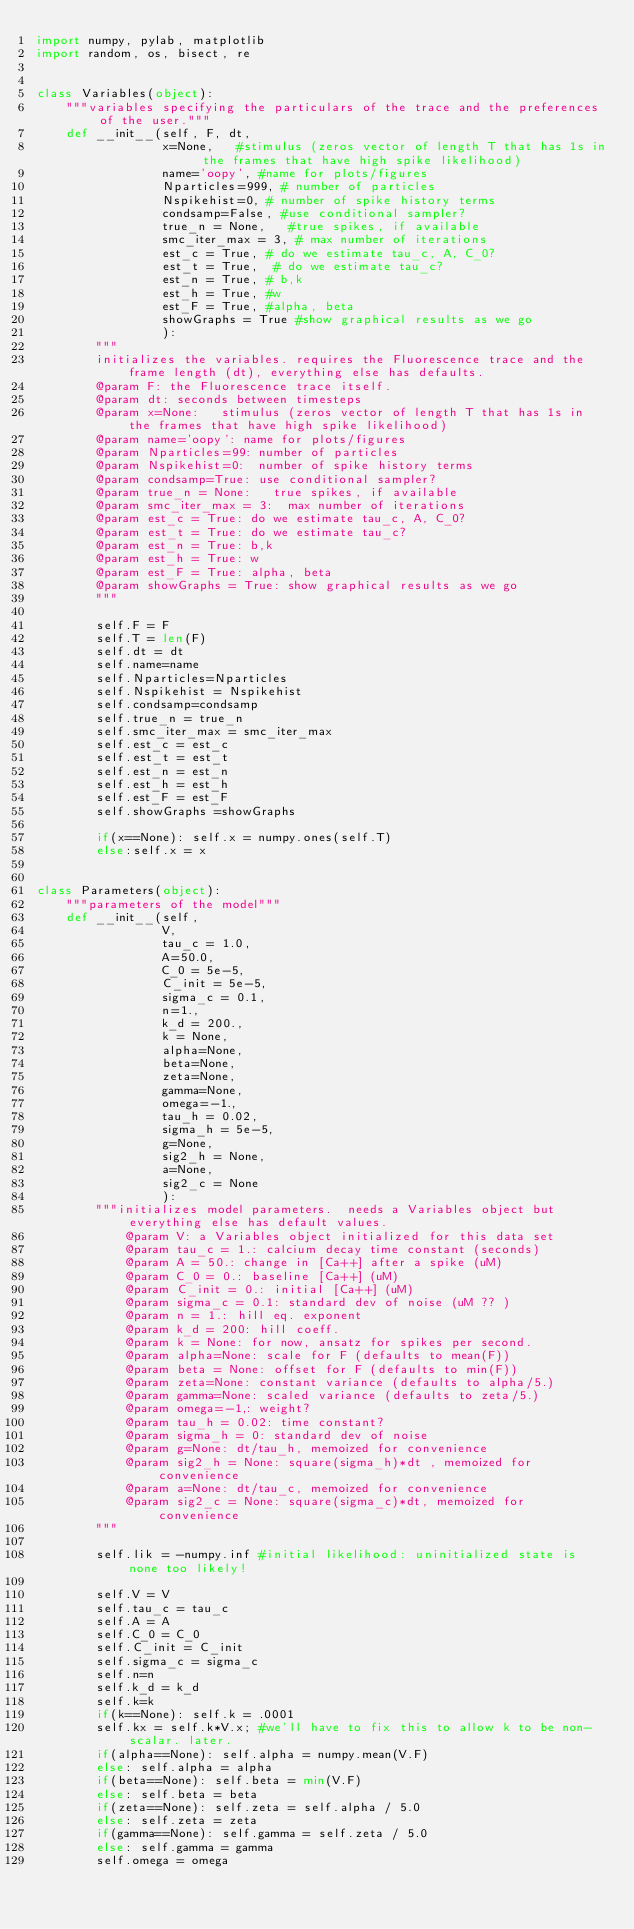<code> <loc_0><loc_0><loc_500><loc_500><_Python_>import numpy, pylab, matplotlib
import random, os, bisect, re


class Variables(object):
    """variables specifying the particulars of the trace and the preferences of the user."""
    def __init__(self, F, dt, 
                 x=None,   #stimulus (zeros vector of length T that has 1s in the frames that have high spike likelihood)
                 name='oopy', #name for plots/figures
                 Nparticles=999, # number of particles
                 Nspikehist=0, # number of spike history terms
                 condsamp=False, #use conditional sampler?
                 true_n = None,   #true spikes, if available
                 smc_iter_max = 3, # max number of iterations
                 est_c = True, # do we estimate tau_c, A, C_0?
                 est_t = True,  # do we estimate tau_c?
                 est_n = True, # b,k
                 est_h = True, #w
                 est_F = True, #alpha, beta
                 showGraphs = True #show graphical results as we go
                 ):
        """
        initializes the variables. requires the Fluorescence trace and the frame length (dt), everything else has defaults.
        @param F: the Fluorescence trace itself.
        @param dt: seconds between timesteps
        @param x=None:   stimulus (zeros vector of length T that has 1s in the frames that have high spike likelihood)
        @param name='oopy': name for plots/figures
        @param Nparticles=99: number of particles
        @param Nspikehist=0:  number of spike history terms
        @param condsamp=True: use conditional sampler?
        @param true_n = None:   true spikes, if available
        @param smc_iter_max = 3:  max number of iterations
        @param est_c = True: do we estimate tau_c, A, C_0?
        @param est_t = True: do we estimate tau_c?
        @param est_n = True: b,k
        @param est_h = True: w
        @param est_F = True: alpha, beta
        @param showGraphs = True: show graphical results as we go
        """
       
        self.F = F
        self.T = len(F)
        self.dt = dt
        self.name=name
        self.Nparticles=Nparticles
        self.Nspikehist = Nspikehist
        self.condsamp=condsamp
        self.true_n = true_n
        self.smc_iter_max = smc_iter_max
        self.est_c = est_c
        self.est_t = est_t
        self.est_n = est_n
        self.est_h = est_h
        self.est_F = est_F
        self.showGraphs =showGraphs
        
        if(x==None): self.x = numpy.ones(self.T)
        else:self.x = x
        

class Parameters(object):
    """parameters of the model"""
    def __init__(self, 
                 V, 
                 tau_c = 1.0,
                 A=50.0,
                 C_0 = 5e-5,
                 C_init = 5e-5,
                 sigma_c = 0.1,
                 n=1.,
                 k_d = 200.,
                 k = None,
                 alpha=None,
                 beta=None, 
                 zeta=None,
                 gamma=None,
                 omega=-1.,
                 tau_h = 0.02,
                 sigma_h = 5e-5,
                 g=None,
                 sig2_h = None,
                 a=None,
                 sig2_c = None
                 ):
        """initializes model parameters.  needs a Variables object but everything else has default values.
            @param V: a Variables object initialized for this data set 
            @param tau_c = 1.: calcium decay time constant (seconds)
            @param A = 50.: change in [Ca++] after a spike (uM)
            @param C_0 = 0.: baseline [Ca++] (uM)
            @param C_init = 0.: initial [Ca++] (uM)
            @param sigma_c = 0.1: standard dev of noise (uM ?? )
            @param n = 1.: hill eq. exponent
            @param k_d = 200: hill coeff.
            @param k = None: for now, ansatz for spikes per second. 
            @param alpha=None: scale for F (defaults to mean(F))
            @param beta = None: offset for F (defaults to min(F))
            @param zeta=None: constant variance (defaults to alpha/5.)
            @param gamma=None: scaled variance (defaults to zeta/5.)
            @param omega=-1,: weight?
            @param tau_h = 0.02: time constant?
            @param sigma_h = 0: standard dev of noise
            @param g=None: dt/tau_h, memoized for convenience
            @param sig2_h = None: square(sigma_h)*dt , memoized for convenience
            @param a=None: dt/tau_c, memoized for convenience
            @param sig2_c = None: square(sigma_c)*dt, memoized for convenience
        """
        
        self.lik = -numpy.inf #initial likelihood: uninitialized state is none too likely!
        
        self.V = V
        self.tau_c = tau_c
        self.A = A
        self.C_0 = C_0
        self.C_init = C_init
        self.sigma_c = sigma_c
        self.n=n
        self.k_d = k_d
        self.k=k
        if(k==None): self.k = .0001
        self.kx = self.k*V.x; #we'll have to fix this to allow k to be non-scalar. later. 
        if(alpha==None): self.alpha = numpy.mean(V.F)
        else: self.alpha = alpha
        if(beta==None): self.beta = min(V.F)
        else: self.beta = beta
        if(zeta==None): self.zeta = self.alpha / 5.0
        else: self.zeta = zeta
        if(gamma==None): self.gamma = self.zeta / 5.0
        else: self.gamma = gamma
        self.omega = omega</code> 